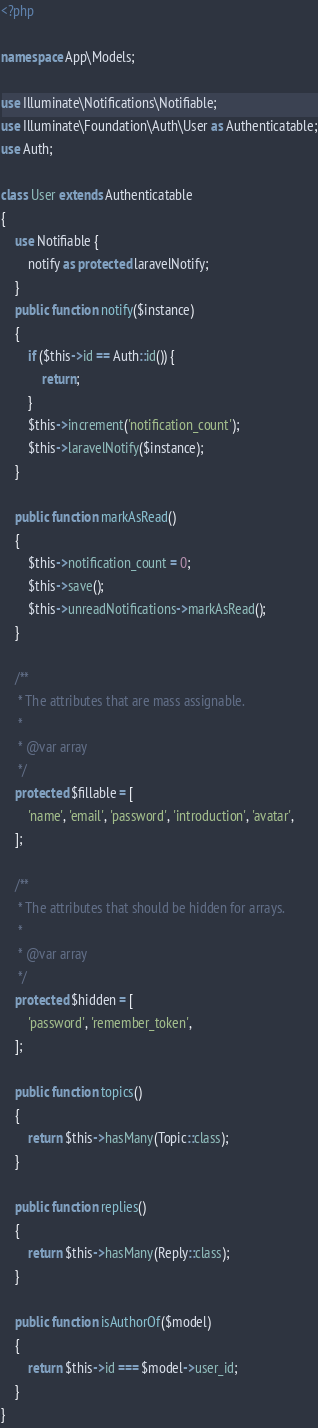Convert code to text. <code><loc_0><loc_0><loc_500><loc_500><_PHP_><?php

namespace App\Models;

use Illuminate\Notifications\Notifiable;
use Illuminate\Foundation\Auth\User as Authenticatable;
use Auth;

class User extends Authenticatable
{
    use Notifiable {
        notify as protected laravelNotify;
    }
    public function notify($instance)
    {
        if ($this->id == Auth::id()) {
            return;
        }
        $this->increment('notification_count');
        $this->laravelNotify($instance);
    }

    public function markAsRead()
    {
        $this->notification_count = 0;
        $this->save();
        $this->unreadNotifications->markAsRead();
    }

    /**
     * The attributes that are mass assignable.
     *
     * @var array
     */
    protected $fillable = [
        'name', 'email', 'password', 'introduction', 'avatar',
    ];

    /**
     * The attributes that should be hidden for arrays.
     *
     * @var array
     */
    protected $hidden = [
        'password', 'remember_token',
    ];

    public function topics()
    {
        return $this->hasMany(Topic::class);
    }

    public function replies()
    {
        return $this->hasMany(Reply::class);
    }

    public function isAuthorOf($model)
    {
        return $this->id === $model->user_id;
    }
}
</code> 